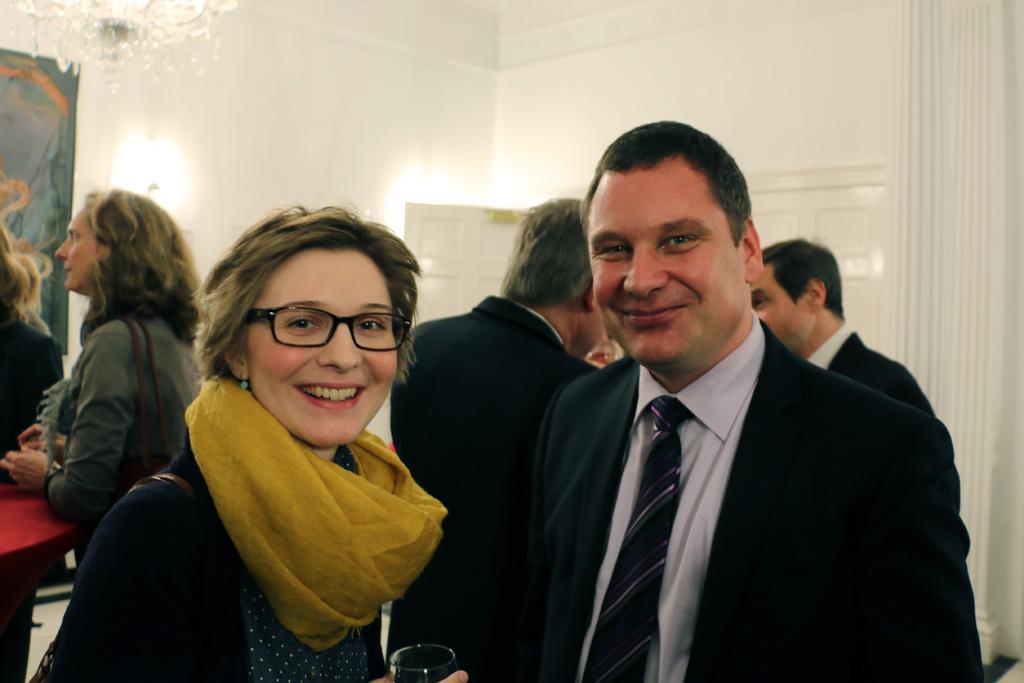Describe this image in one or two sentences. In this picture we can see a group of people are standing. Behind the people there is a wall and a chandelier. 